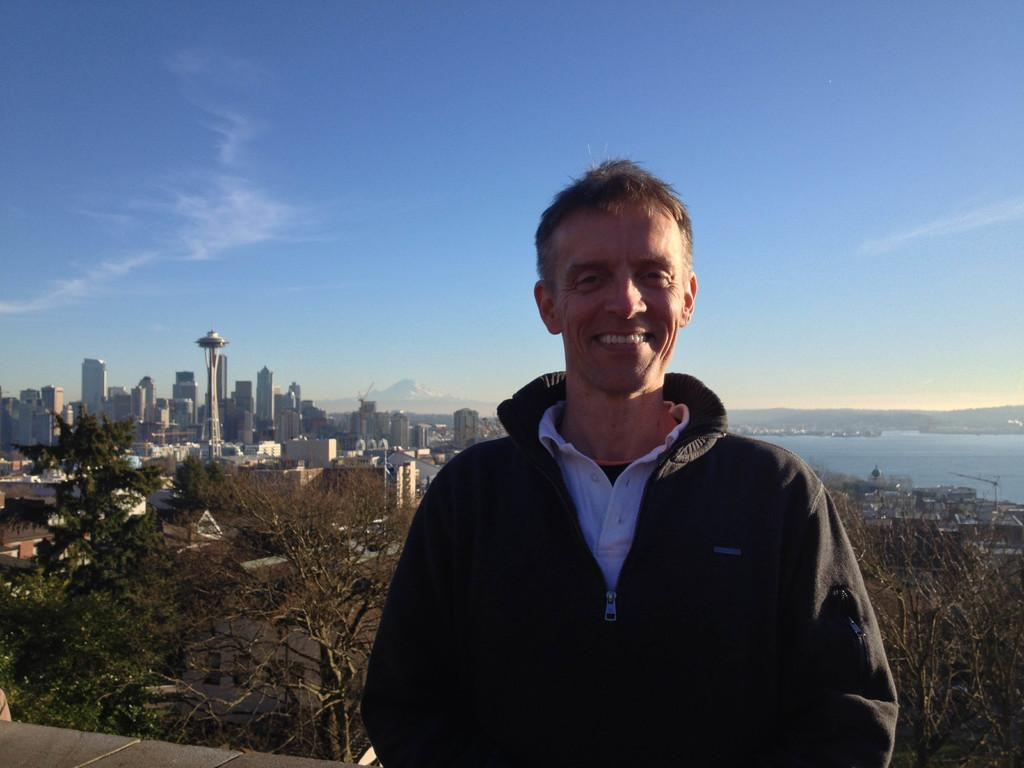Who or what is the main subject in the image? There is a person in the image. What can be seen behind the person? There are trees behind the person. What type of structures are visible in the image? There are buildings visible in the image. What is visible at the top of the image? The sky is visible at the top of the image. What natural feature can be seen on the right side of the image? There is water on the right side of the image. What type of landform is present in the image? There is a hill in the image. What type of heart condition does the person in the image have? There is no information about the person's health in the image, so it is not possible to determine if they have a heart condition. Is the doctor in the image examining the person's tongue? There is no doctor or tongue present in the image. 